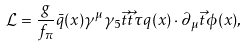<formula> <loc_0><loc_0><loc_500><loc_500>\mathcal { L } = \frac { g } { f _ { \pi } } \bar { q } ( x ) \gamma ^ { \mu } \gamma _ { 5 } \vec { t } { \vec { t } { \tau } } q ( x ) \cdot \partial _ { \mu } \vec { t } { \phi } ( x ) ,</formula> 